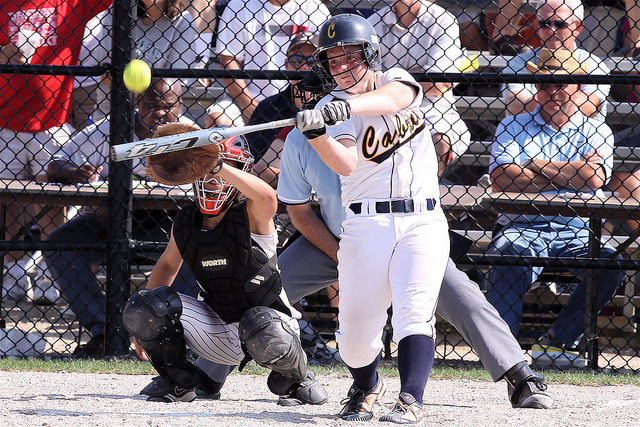Can you describe the stance of the catcher? Certainly. The catcher is in a classic crouched stance, with their glove extended forward in anticipation of catching the ball. Additionally, the catcher is wearing comprehensive protective gear including a mask, chest protector, and leg guards. 